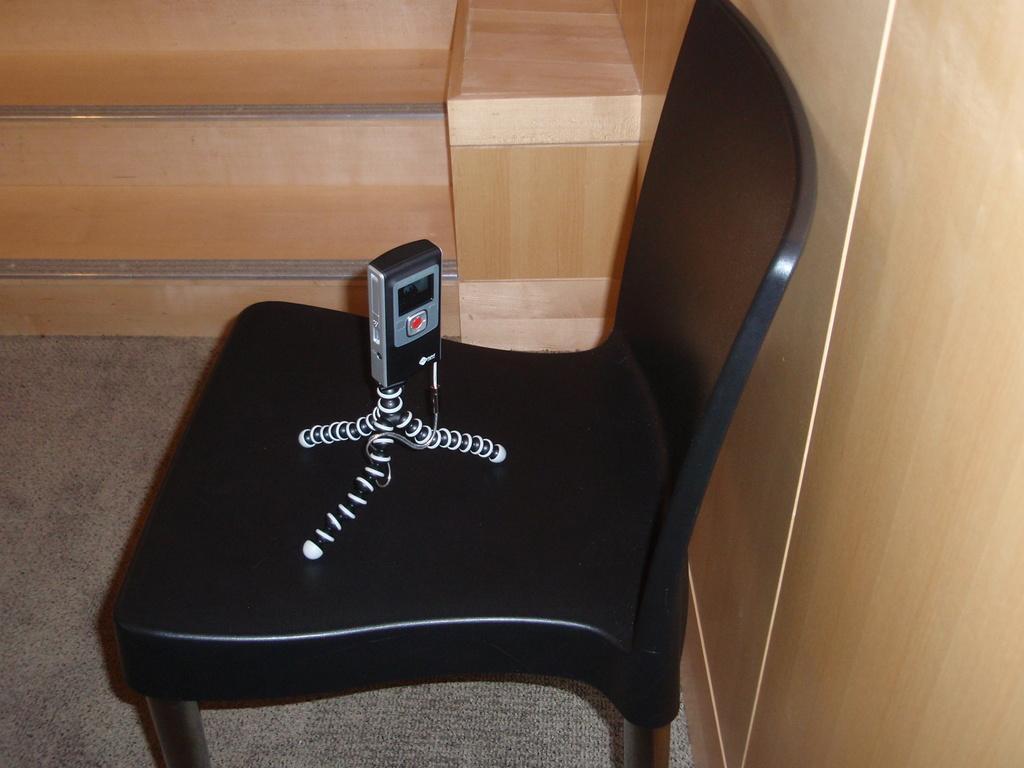Please provide a concise description of this image. In this image I can see a chair on which some object is kept, steps and a wooden wall. This image is taken may be in a room. 